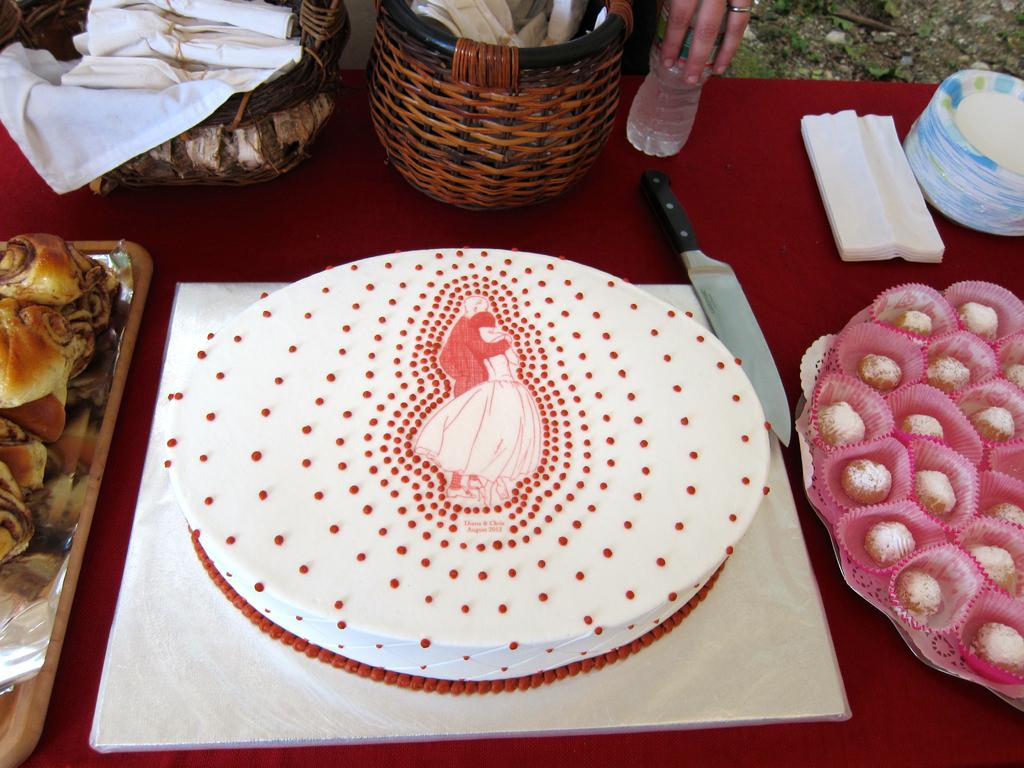What type of food items can be seen in the image? There are sweets and cakes in the image. What utensil is present in the image? There is a knife in the image. What type of container is visible in the image? There is a bottle in the image. What type of storage item is present in the image? There are baskets in the image. Where are the objects placed in the image? The objects are placed on a table. Whose hand is visible in the image? A person's hand is visible in the image. What type of chair is used to support the sweater in the image? There is no chair or sweater present in the image. What is the current status of the sweets in the image? The provided facts do not mention any information about the current status of the sweets. 